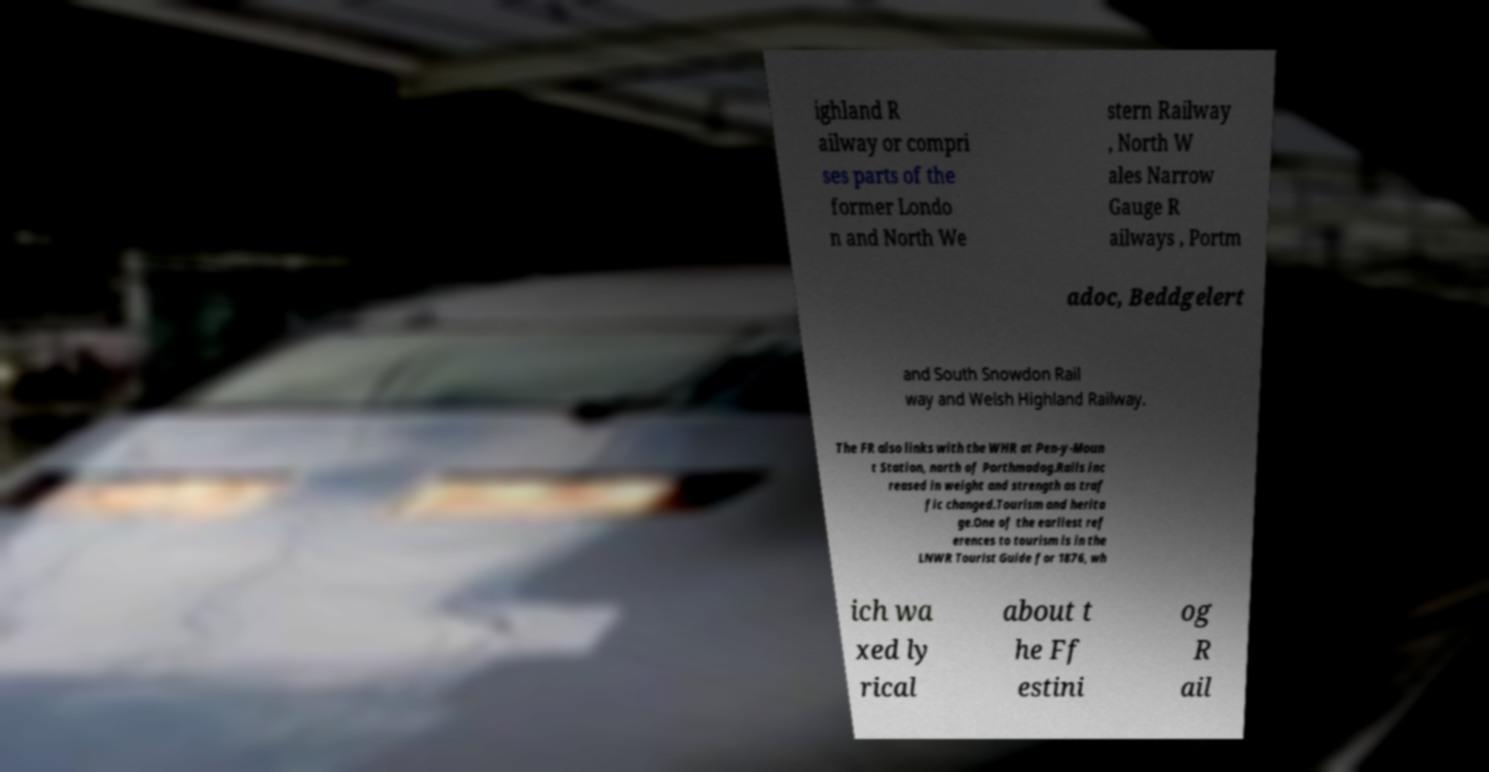Please identify and transcribe the text found in this image. ighland R ailway or compri ses parts of the former Londo n and North We stern Railway , North W ales Narrow Gauge R ailways , Portm adoc, Beddgelert and South Snowdon Rail way and Welsh Highland Railway. The FR also links with the WHR at Pen-y-Moun t Station, north of Porthmadog.Rails inc reased in weight and strength as traf fic changed.Tourism and herita ge.One of the earliest ref erences to tourism is in the LNWR Tourist Guide for 1876, wh ich wa xed ly rical about t he Ff estini og R ail 